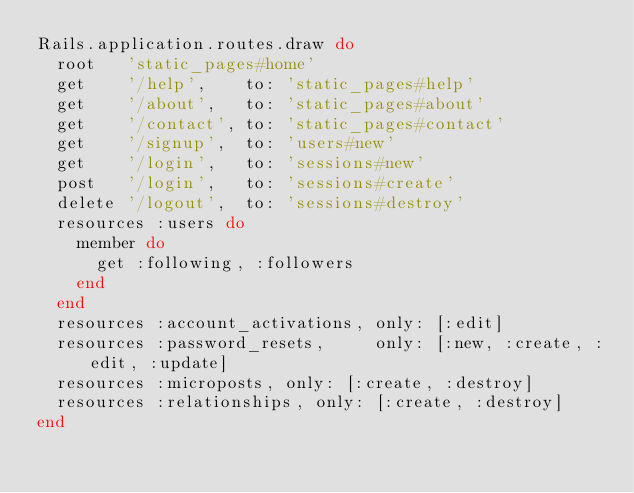Convert code to text. <code><loc_0><loc_0><loc_500><loc_500><_Ruby_>Rails.application.routes.draw do
  root   'static_pages#home'
  get    '/help',    to: 'static_pages#help'
  get    '/about',   to: 'static_pages#about'
  get    '/contact', to: 'static_pages#contact'
  get    '/signup',  to: 'users#new'
  get    '/login',   to: 'sessions#new'
  post   '/login',   to: 'sessions#create'
  delete '/logout',  to: 'sessions#destroy'
  resources :users do
    member do
      get :following, :followers
    end
  end
  resources :account_activations, only: [:edit]
  resources :password_resets,     only: [:new, :create, :edit, :update]
  resources :microposts, only: [:create, :destroy]
  resources :relationships, only: [:create, :destroy]
end</code> 